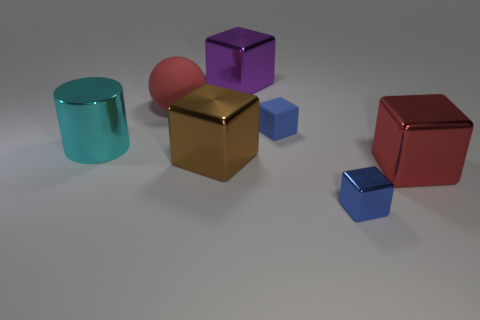Subtract 1 blocks. How many blocks are left? 4 Add 1 metal blocks. How many objects exist? 8 Subtract all cylinders. How many objects are left? 6 Subtract all big red shiny objects. Subtract all blue things. How many objects are left? 4 Add 5 big red rubber things. How many big red rubber things are left? 6 Add 2 small blue objects. How many small blue objects exist? 4 Subtract 0 gray blocks. How many objects are left? 7 